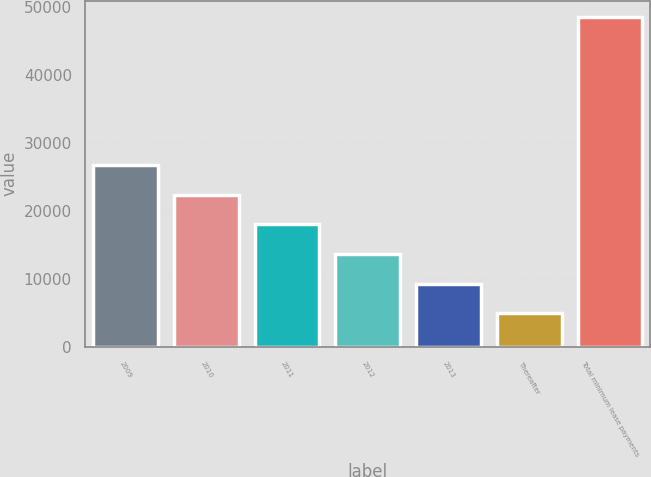<chart> <loc_0><loc_0><loc_500><loc_500><bar_chart><fcel>2009<fcel>2010<fcel>2011<fcel>2012<fcel>2013<fcel>Thereafter<fcel>Total minimum lease payments<nl><fcel>26704.5<fcel>22352.8<fcel>18001.1<fcel>13649.4<fcel>9297.7<fcel>4946<fcel>48463<nl></chart> 